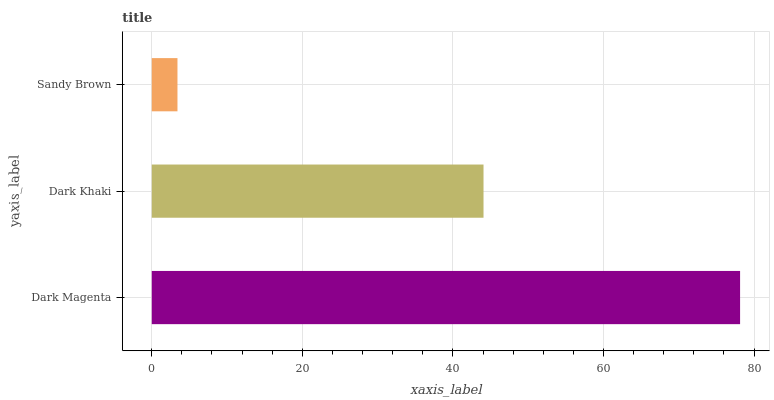Is Sandy Brown the minimum?
Answer yes or no. Yes. Is Dark Magenta the maximum?
Answer yes or no. Yes. Is Dark Khaki the minimum?
Answer yes or no. No. Is Dark Khaki the maximum?
Answer yes or no. No. Is Dark Magenta greater than Dark Khaki?
Answer yes or no. Yes. Is Dark Khaki less than Dark Magenta?
Answer yes or no. Yes. Is Dark Khaki greater than Dark Magenta?
Answer yes or no. No. Is Dark Magenta less than Dark Khaki?
Answer yes or no. No. Is Dark Khaki the high median?
Answer yes or no. Yes. Is Dark Khaki the low median?
Answer yes or no. Yes. Is Dark Magenta the high median?
Answer yes or no. No. Is Sandy Brown the low median?
Answer yes or no. No. 